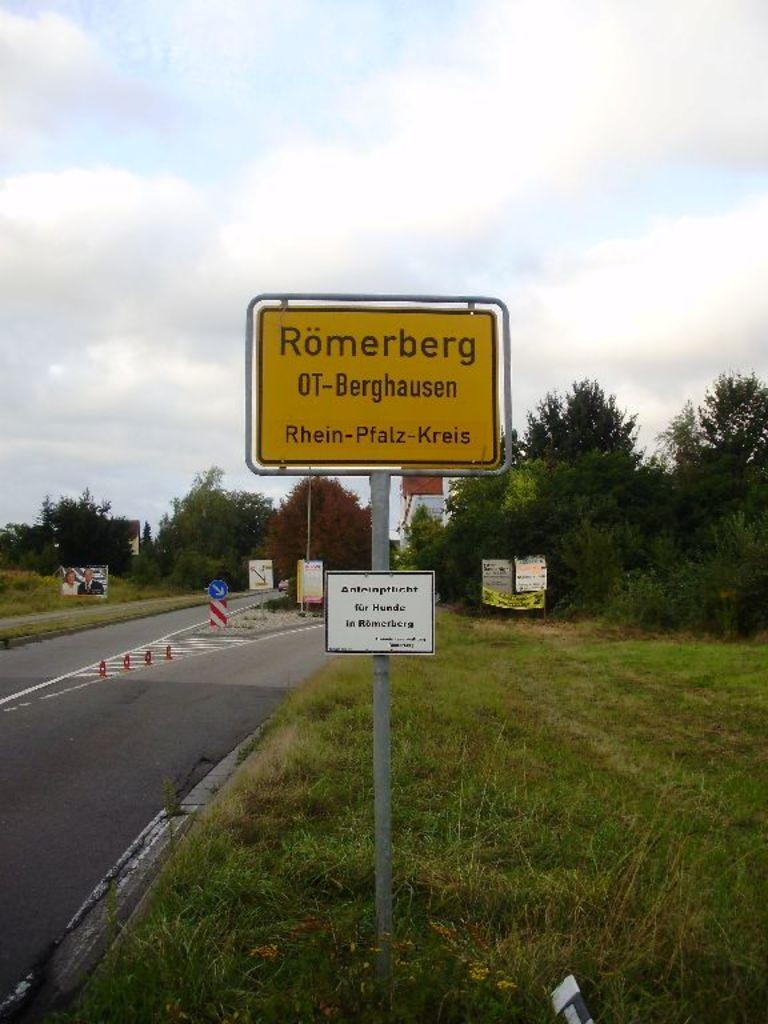What is written on the boards in the image? The facts do not specify the text on the boards, so we cannot answer that question definitively. What type of vegetation is present in the image? There are trees and grass in the image. What type of surface can be seen in the image? There is a road in the image. What is visible in the background of the image? The sky is visible in the background of the image. What type of destruction can be seen in the image? There is no destruction present in the image; it features boards with text, trees, grass, a road, and the sky. What type of cloud is visible in the image? The facts do not specify the type of clouds in the image, so we cannot answer that question definitively. 